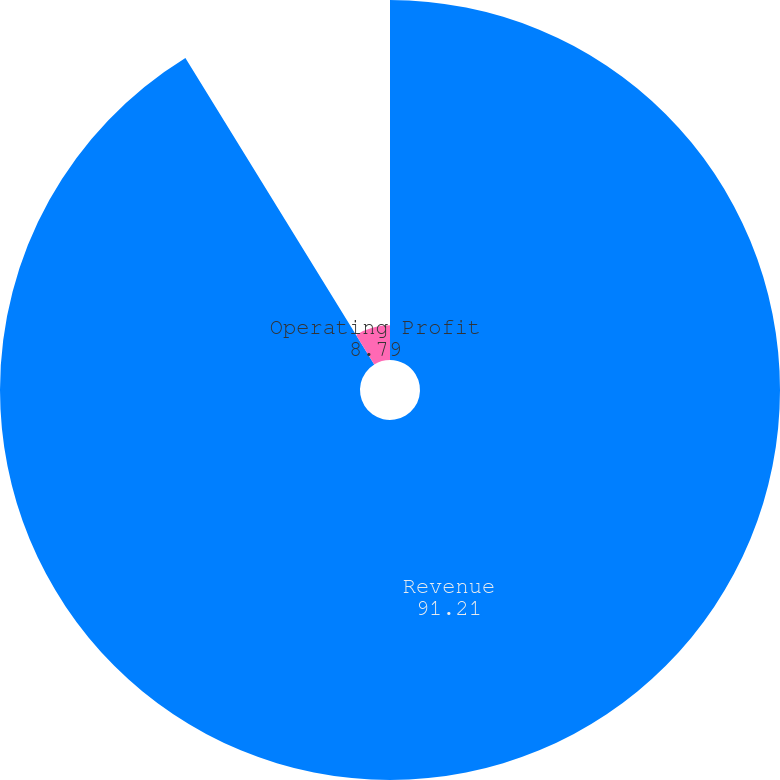Convert chart. <chart><loc_0><loc_0><loc_500><loc_500><pie_chart><fcel>Revenue<fcel>Operating Profit<nl><fcel>91.21%<fcel>8.79%<nl></chart> 